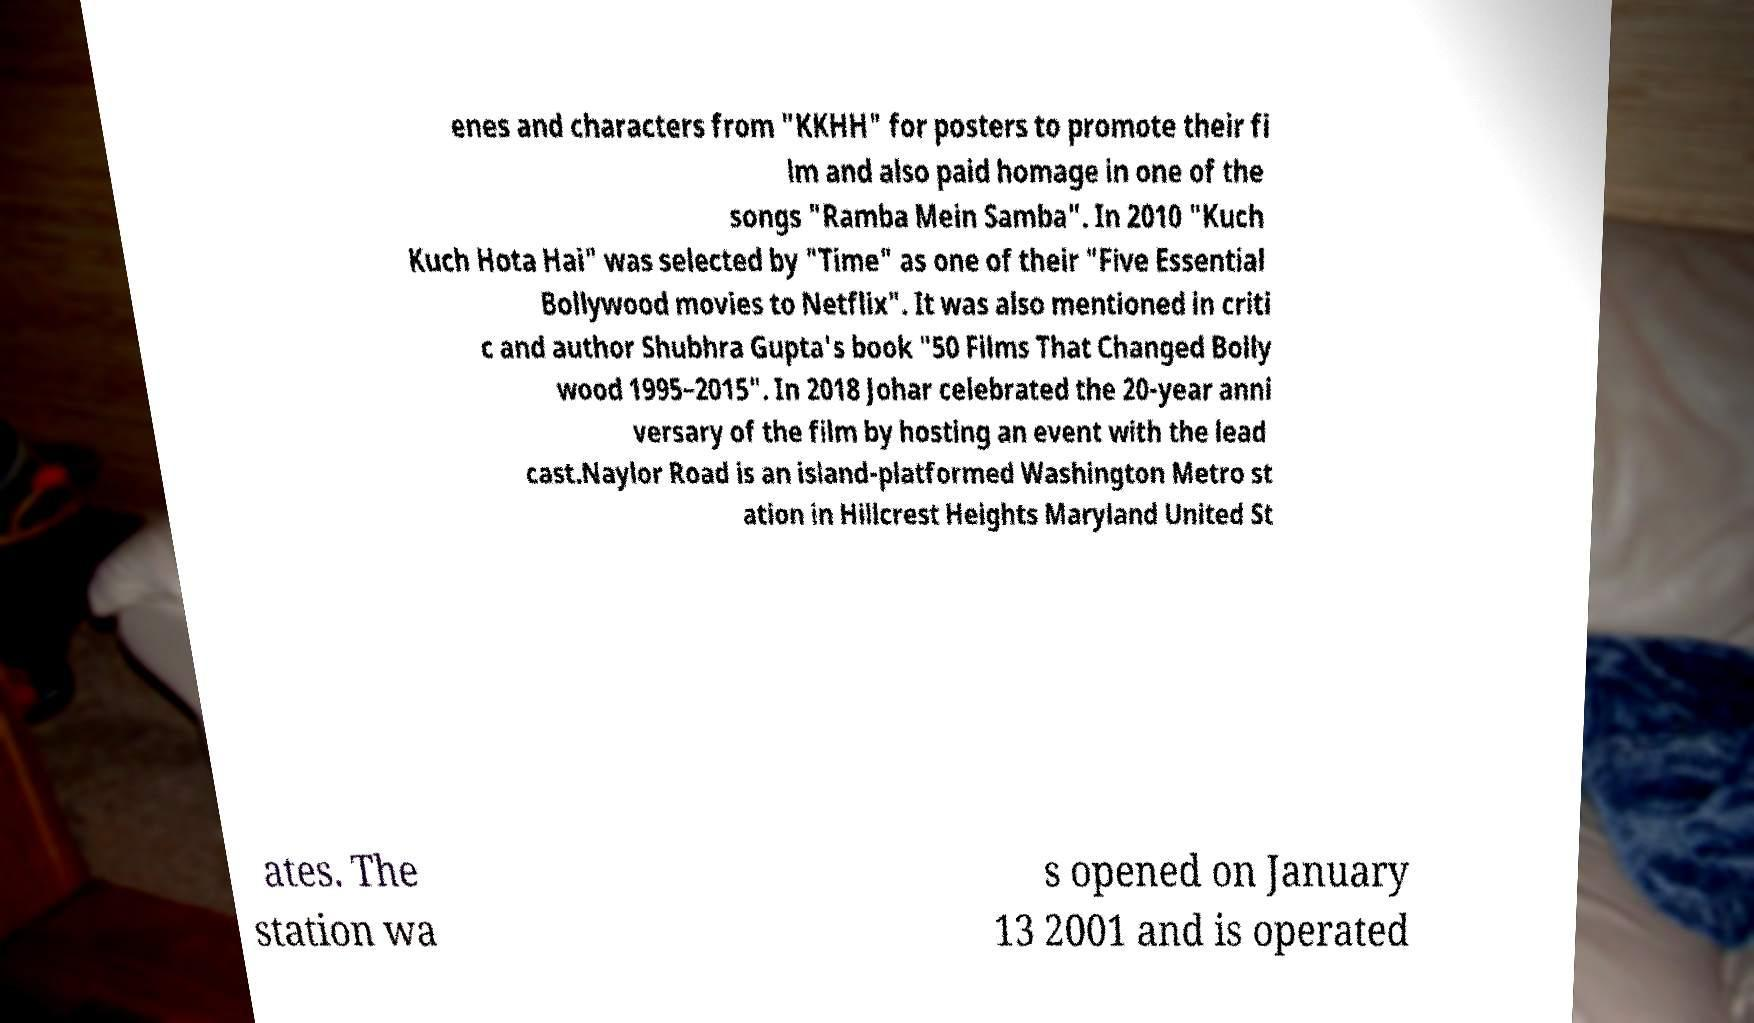Could you extract and type out the text from this image? enes and characters from "KKHH" for posters to promote their fi lm and also paid homage in one of the songs "Ramba Mein Samba". In 2010 "Kuch Kuch Hota Hai" was selected by "Time" as one of their "Five Essential Bollywood movies to Netflix". It was also mentioned in criti c and author Shubhra Gupta's book "50 Films That Changed Bolly wood 1995–2015". In 2018 Johar celebrated the 20-year anni versary of the film by hosting an event with the lead cast.Naylor Road is an island-platformed Washington Metro st ation in Hillcrest Heights Maryland United St ates. The station wa s opened on January 13 2001 and is operated 